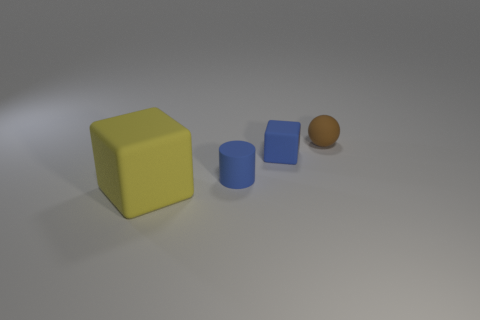Add 2 large gray metallic blocks. How many objects exist? 6 Subtract all cylinders. How many objects are left? 3 Add 4 green metal cylinders. How many green metal cylinders exist? 4 Subtract 1 yellow blocks. How many objects are left? 3 Subtract all tiny blue things. Subtract all small green rubber cylinders. How many objects are left? 2 Add 2 blue rubber things. How many blue rubber things are left? 4 